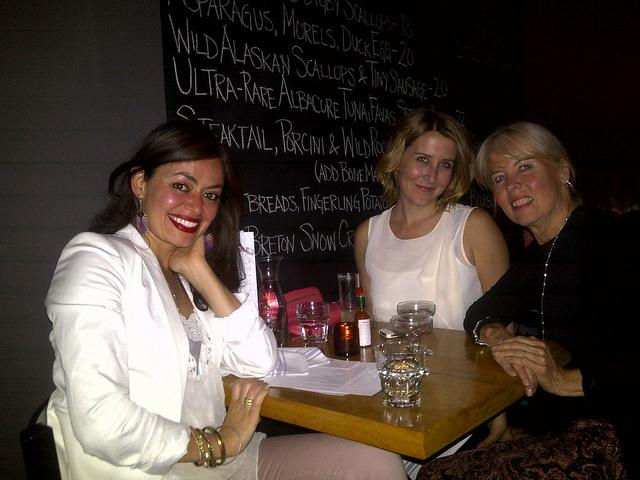What is this place? bar 